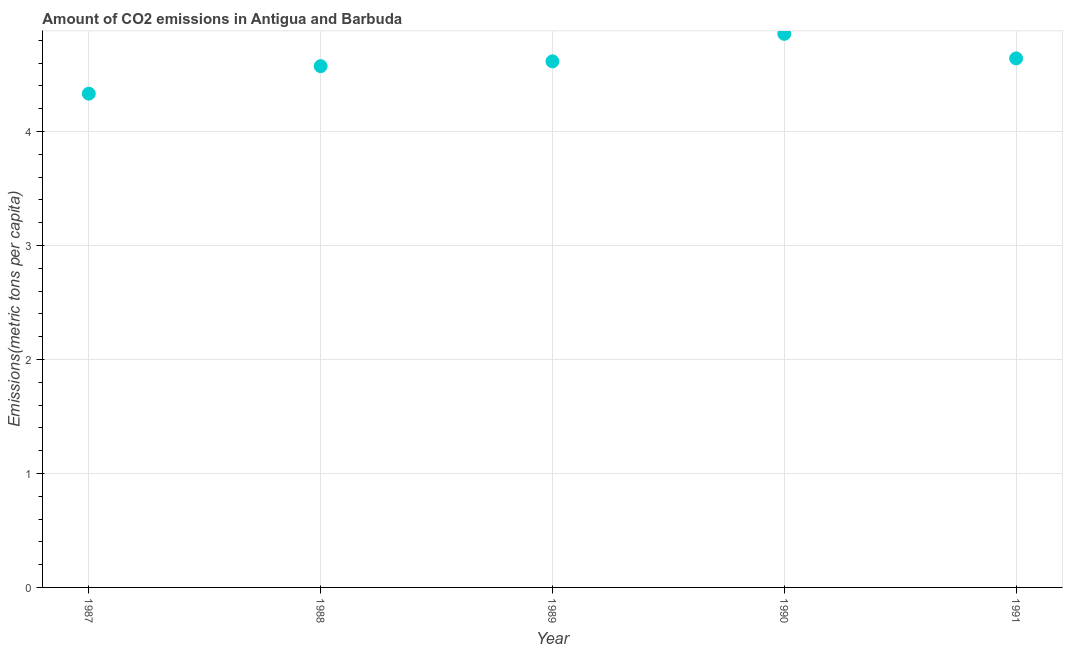What is the amount of co2 emissions in 1989?
Ensure brevity in your answer.  4.62. Across all years, what is the maximum amount of co2 emissions?
Offer a very short reply. 4.86. Across all years, what is the minimum amount of co2 emissions?
Give a very brief answer. 4.33. In which year was the amount of co2 emissions minimum?
Your response must be concise. 1987. What is the sum of the amount of co2 emissions?
Ensure brevity in your answer.  23.02. What is the difference between the amount of co2 emissions in 1987 and 1988?
Your answer should be very brief. -0.24. What is the average amount of co2 emissions per year?
Provide a short and direct response. 4.6. What is the median amount of co2 emissions?
Offer a terse response. 4.62. In how many years, is the amount of co2 emissions greater than 1.8 metric tons per capita?
Make the answer very short. 5. Do a majority of the years between 1988 and 1991 (inclusive) have amount of co2 emissions greater than 1.8 metric tons per capita?
Offer a very short reply. Yes. What is the ratio of the amount of co2 emissions in 1989 to that in 1990?
Offer a very short reply. 0.95. Is the amount of co2 emissions in 1987 less than that in 1989?
Give a very brief answer. Yes. What is the difference between the highest and the second highest amount of co2 emissions?
Your answer should be compact. 0.22. What is the difference between the highest and the lowest amount of co2 emissions?
Give a very brief answer. 0.53. What is the difference between two consecutive major ticks on the Y-axis?
Give a very brief answer. 1. Does the graph contain any zero values?
Provide a short and direct response. No. What is the title of the graph?
Your response must be concise. Amount of CO2 emissions in Antigua and Barbuda. What is the label or title of the X-axis?
Provide a succinct answer. Year. What is the label or title of the Y-axis?
Ensure brevity in your answer.  Emissions(metric tons per capita). What is the Emissions(metric tons per capita) in 1987?
Your response must be concise. 4.33. What is the Emissions(metric tons per capita) in 1988?
Offer a very short reply. 4.57. What is the Emissions(metric tons per capita) in 1989?
Keep it short and to the point. 4.62. What is the Emissions(metric tons per capita) in 1990?
Keep it short and to the point. 4.86. What is the Emissions(metric tons per capita) in 1991?
Your answer should be very brief. 4.64. What is the difference between the Emissions(metric tons per capita) in 1987 and 1988?
Ensure brevity in your answer.  -0.24. What is the difference between the Emissions(metric tons per capita) in 1987 and 1989?
Your answer should be compact. -0.28. What is the difference between the Emissions(metric tons per capita) in 1987 and 1990?
Ensure brevity in your answer.  -0.53. What is the difference between the Emissions(metric tons per capita) in 1987 and 1991?
Ensure brevity in your answer.  -0.31. What is the difference between the Emissions(metric tons per capita) in 1988 and 1989?
Your answer should be compact. -0.04. What is the difference between the Emissions(metric tons per capita) in 1988 and 1990?
Your response must be concise. -0.28. What is the difference between the Emissions(metric tons per capita) in 1988 and 1991?
Offer a very short reply. -0.07. What is the difference between the Emissions(metric tons per capita) in 1989 and 1990?
Provide a short and direct response. -0.24. What is the difference between the Emissions(metric tons per capita) in 1989 and 1991?
Keep it short and to the point. -0.03. What is the difference between the Emissions(metric tons per capita) in 1990 and 1991?
Give a very brief answer. 0.22. What is the ratio of the Emissions(metric tons per capita) in 1987 to that in 1988?
Offer a terse response. 0.95. What is the ratio of the Emissions(metric tons per capita) in 1987 to that in 1989?
Give a very brief answer. 0.94. What is the ratio of the Emissions(metric tons per capita) in 1987 to that in 1990?
Your answer should be compact. 0.89. What is the ratio of the Emissions(metric tons per capita) in 1987 to that in 1991?
Give a very brief answer. 0.93. What is the ratio of the Emissions(metric tons per capita) in 1988 to that in 1990?
Your answer should be compact. 0.94. What is the ratio of the Emissions(metric tons per capita) in 1989 to that in 1990?
Your answer should be very brief. 0.95. What is the ratio of the Emissions(metric tons per capita) in 1990 to that in 1991?
Offer a terse response. 1.05. 